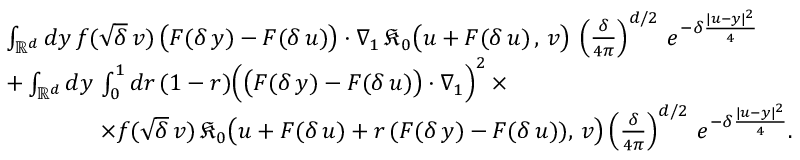<formula> <loc_0><loc_0><loc_500><loc_500>\begin{array} { r l } & { \int _ { \mathbb { R } ^ { d } } d y \, f ( \sqrt { \delta } \, v ) \, \left ( F ( \delta \, y ) - F ( \delta \, u ) \right ) \cdot \nabla _ { 1 } \, \mathfrak { K } _ { 0 } \left ( u + F ( \delta \, u ) \, , \, v \right ) \, \left ( \frac { \delta } { 4 \pi } \right ) ^ { d / 2 } \, e ^ { - \delta \frac { | u - y | ^ { 2 } } { 4 } } } \\ & { + \int _ { \mathbb { R } ^ { d } } d y \, \int _ { 0 } ^ { 1 } d r \, ( 1 - r ) \left ( \left ( F ( \delta \, y ) - F ( \delta \, u ) \right ) \cdot \nabla _ { 1 } \right ) ^ { 2 } \, \times } \\ & { \quad \times f ( \sqrt { \delta } \, v ) \, \mathfrak { K } _ { 0 } \left ( u + F ( \delta \, u ) + r \, ( F ( \delta \, y ) - F ( \delta \, u ) ) , \, v \right ) \left ( \frac { \delta } { 4 \pi } \right ) ^ { d / 2 } \, e ^ { - \delta \frac { | u - y | ^ { 2 } } { 4 } } . } \end{array}</formula> 